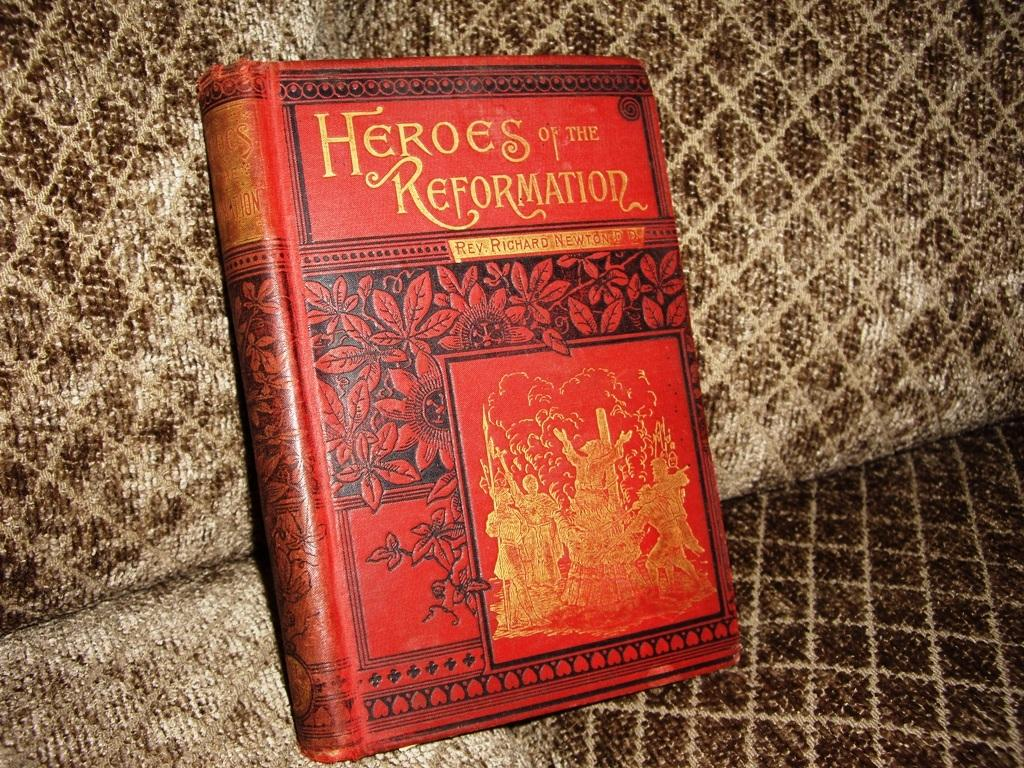Provide a one-sentence caption for the provided image. A red book about a legacy of heroes is on a brown couch. 